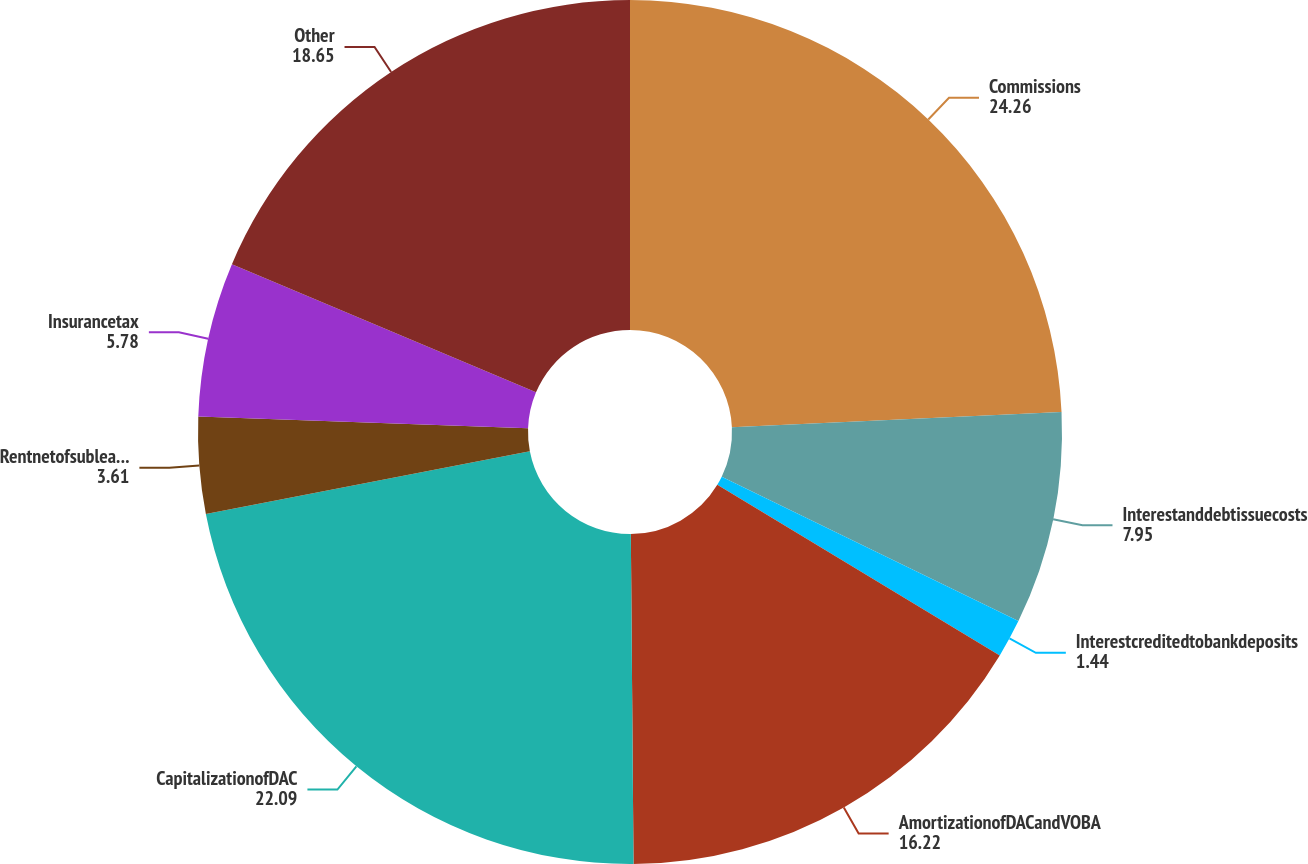<chart> <loc_0><loc_0><loc_500><loc_500><pie_chart><fcel>Commissions<fcel>Interestanddebtissuecosts<fcel>Interestcreditedtobankdeposits<fcel>AmortizationofDACandVOBA<fcel>CapitalizationofDAC<fcel>Rentnetofsubleaseincome<fcel>Insurancetax<fcel>Other<nl><fcel>24.26%<fcel>7.95%<fcel>1.44%<fcel>16.22%<fcel>22.09%<fcel>3.61%<fcel>5.78%<fcel>18.65%<nl></chart> 